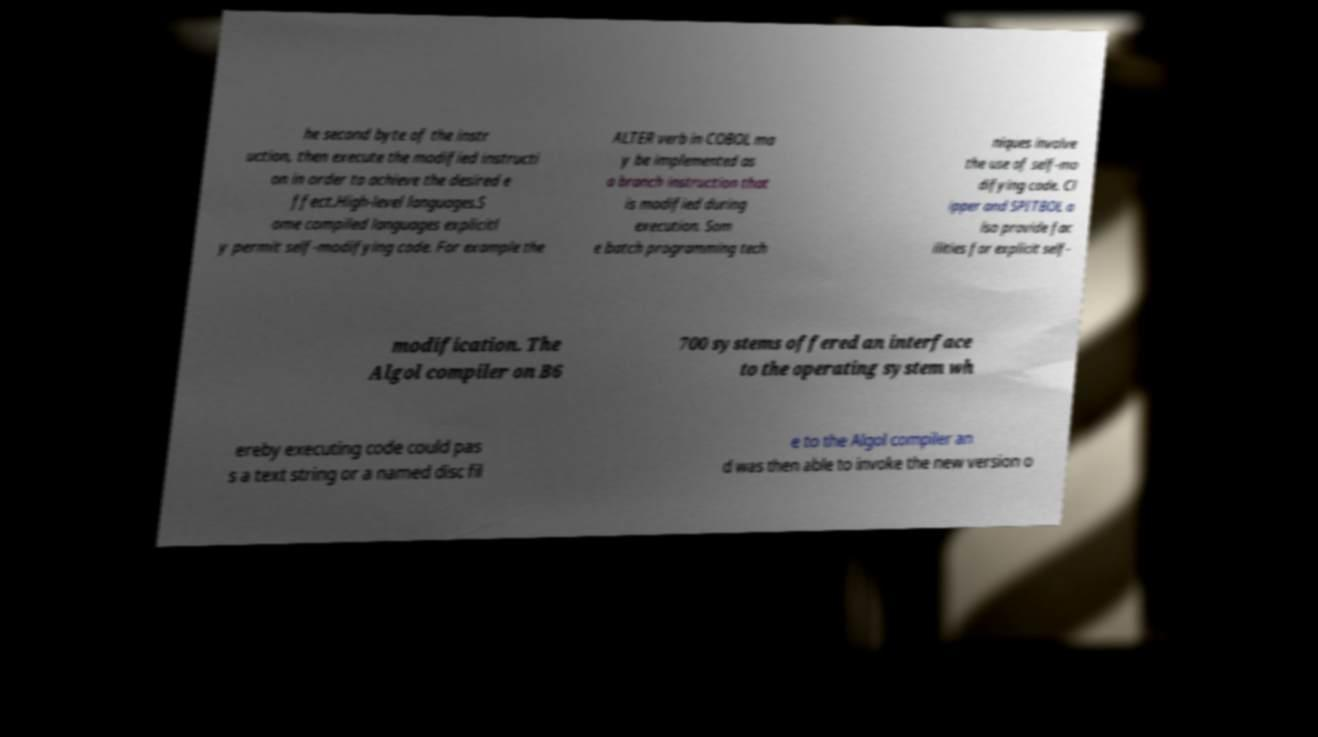I need the written content from this picture converted into text. Can you do that? he second byte of the instr uction, then execute the modified instructi on in order to achieve the desired e ffect.High-level languages.S ome compiled languages explicitl y permit self-modifying code. For example the ALTER verb in COBOL ma y be implemented as a branch instruction that is modified during execution. Som e batch programming tech niques involve the use of self-mo difying code. Cl ipper and SPITBOL a lso provide fac ilities for explicit self- modification. The Algol compiler on B6 700 systems offered an interface to the operating system wh ereby executing code could pas s a text string or a named disc fil e to the Algol compiler an d was then able to invoke the new version o 